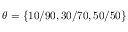Convert formula to latex. <formula><loc_0><loc_0><loc_500><loc_500>\theta = \{ 1 0 / 9 0 , 3 0 / 7 0 , 5 0 / 5 0 \}</formula> 